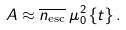<formula> <loc_0><loc_0><loc_500><loc_500>A \approx \overline { n _ { \text {esc} } } \, \mu _ { 0 } ^ { 2 } \, \{ t \} \, .</formula> 